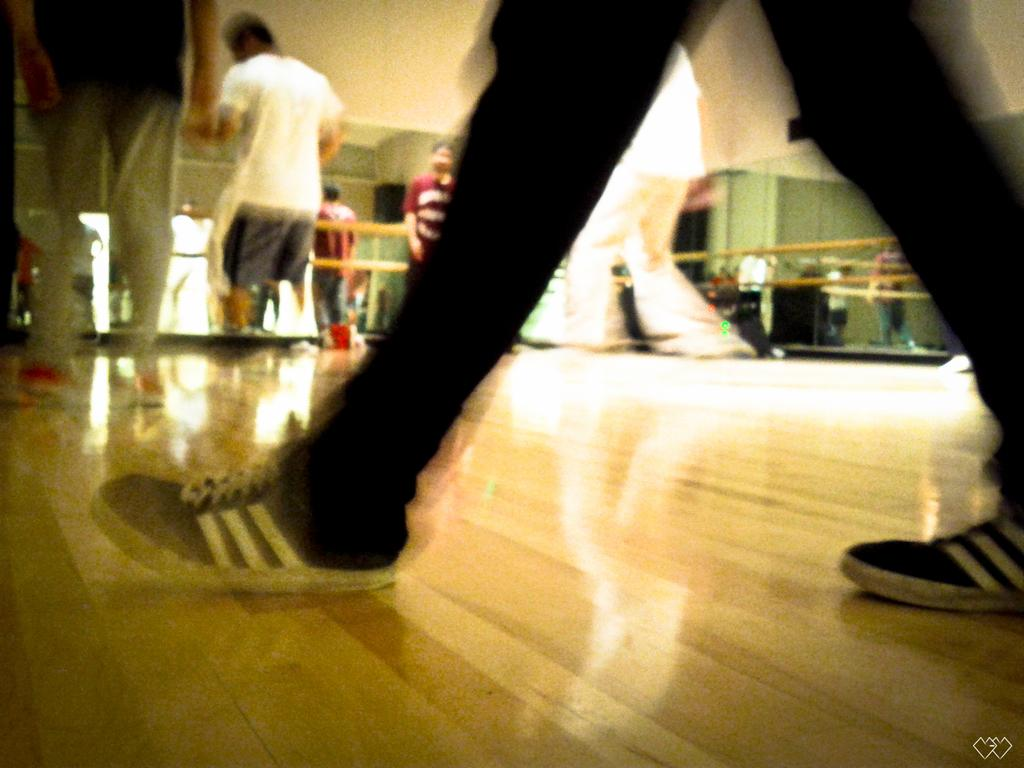How many people are in the image? There are persons in the image, but the exact number is not specified. What can be seen in the background of the image? There is a fence in the background of the image. Where is the logo located in the image? The logo is in the bottom right corner of the image. Can you tell me how many kittens are sitting on the person's knee in the image? There is no kitten or person's knee present in the image. What type of salt is being used by the persons in the image? There is no salt visible in the image. 